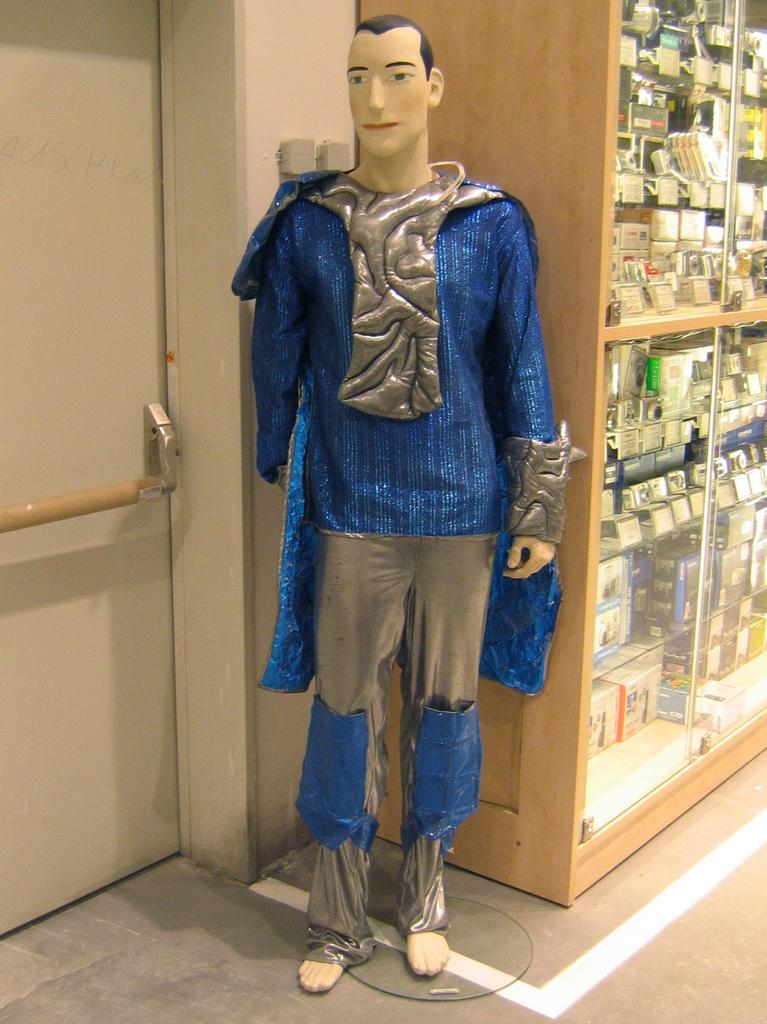What is the main subject of the image? There is a mannequin in the image. What is the mannequin wearing? Clothes are on the mannequin. Can you describe any architectural features in the image? There is a door in the image. What type of storage is visible in the image? Cardboard cartons are arranged in rows inside a cupboard. What type of dock can be seen in the image? There is no dock present in the image. Can you describe the self-awareness of the mannequin in the image? Mannequins are inanimate objects and do not possess self-awareness. 